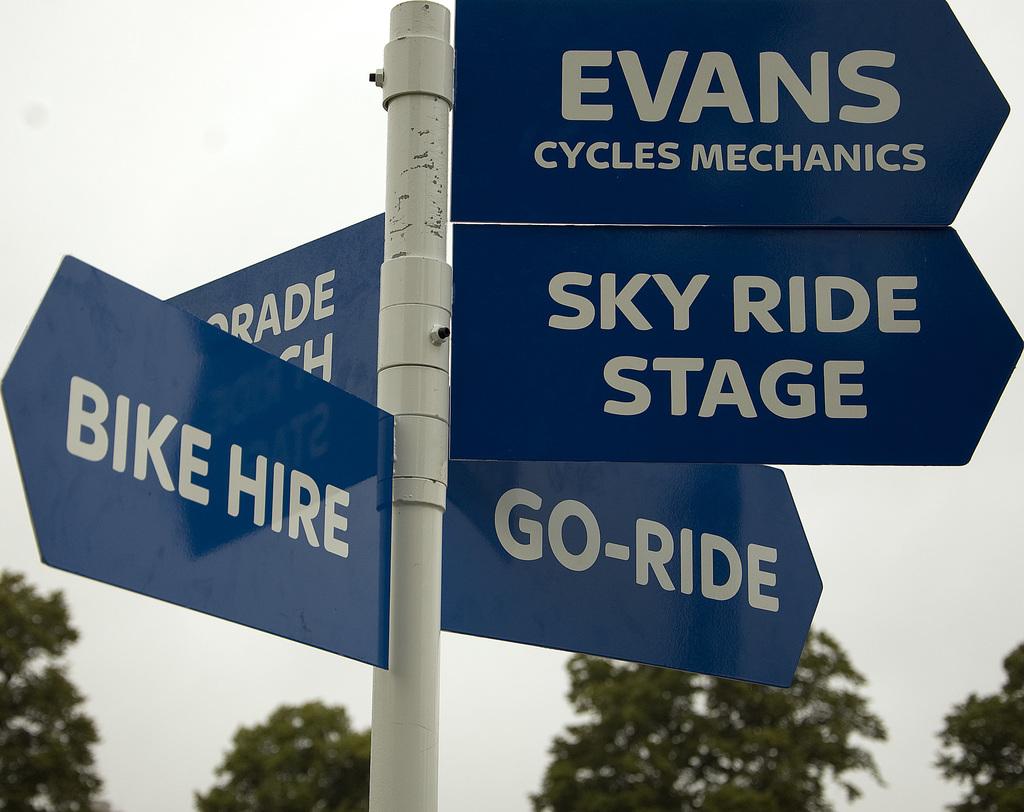What is the name of the cycles mechanics business?
Offer a very short reply. Evans. What does the sign on the left say?
Give a very brief answer. Bike hire. 